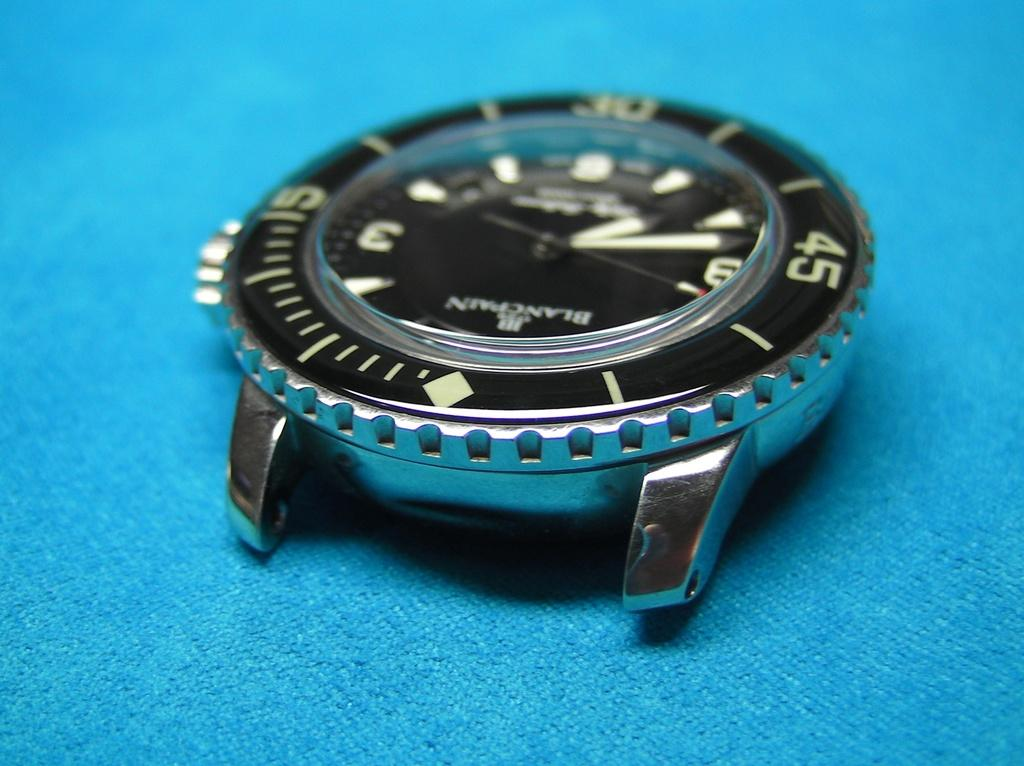<image>
Write a terse but informative summary of the picture. a BlancPain silver and black wrist watch on blue cloth 